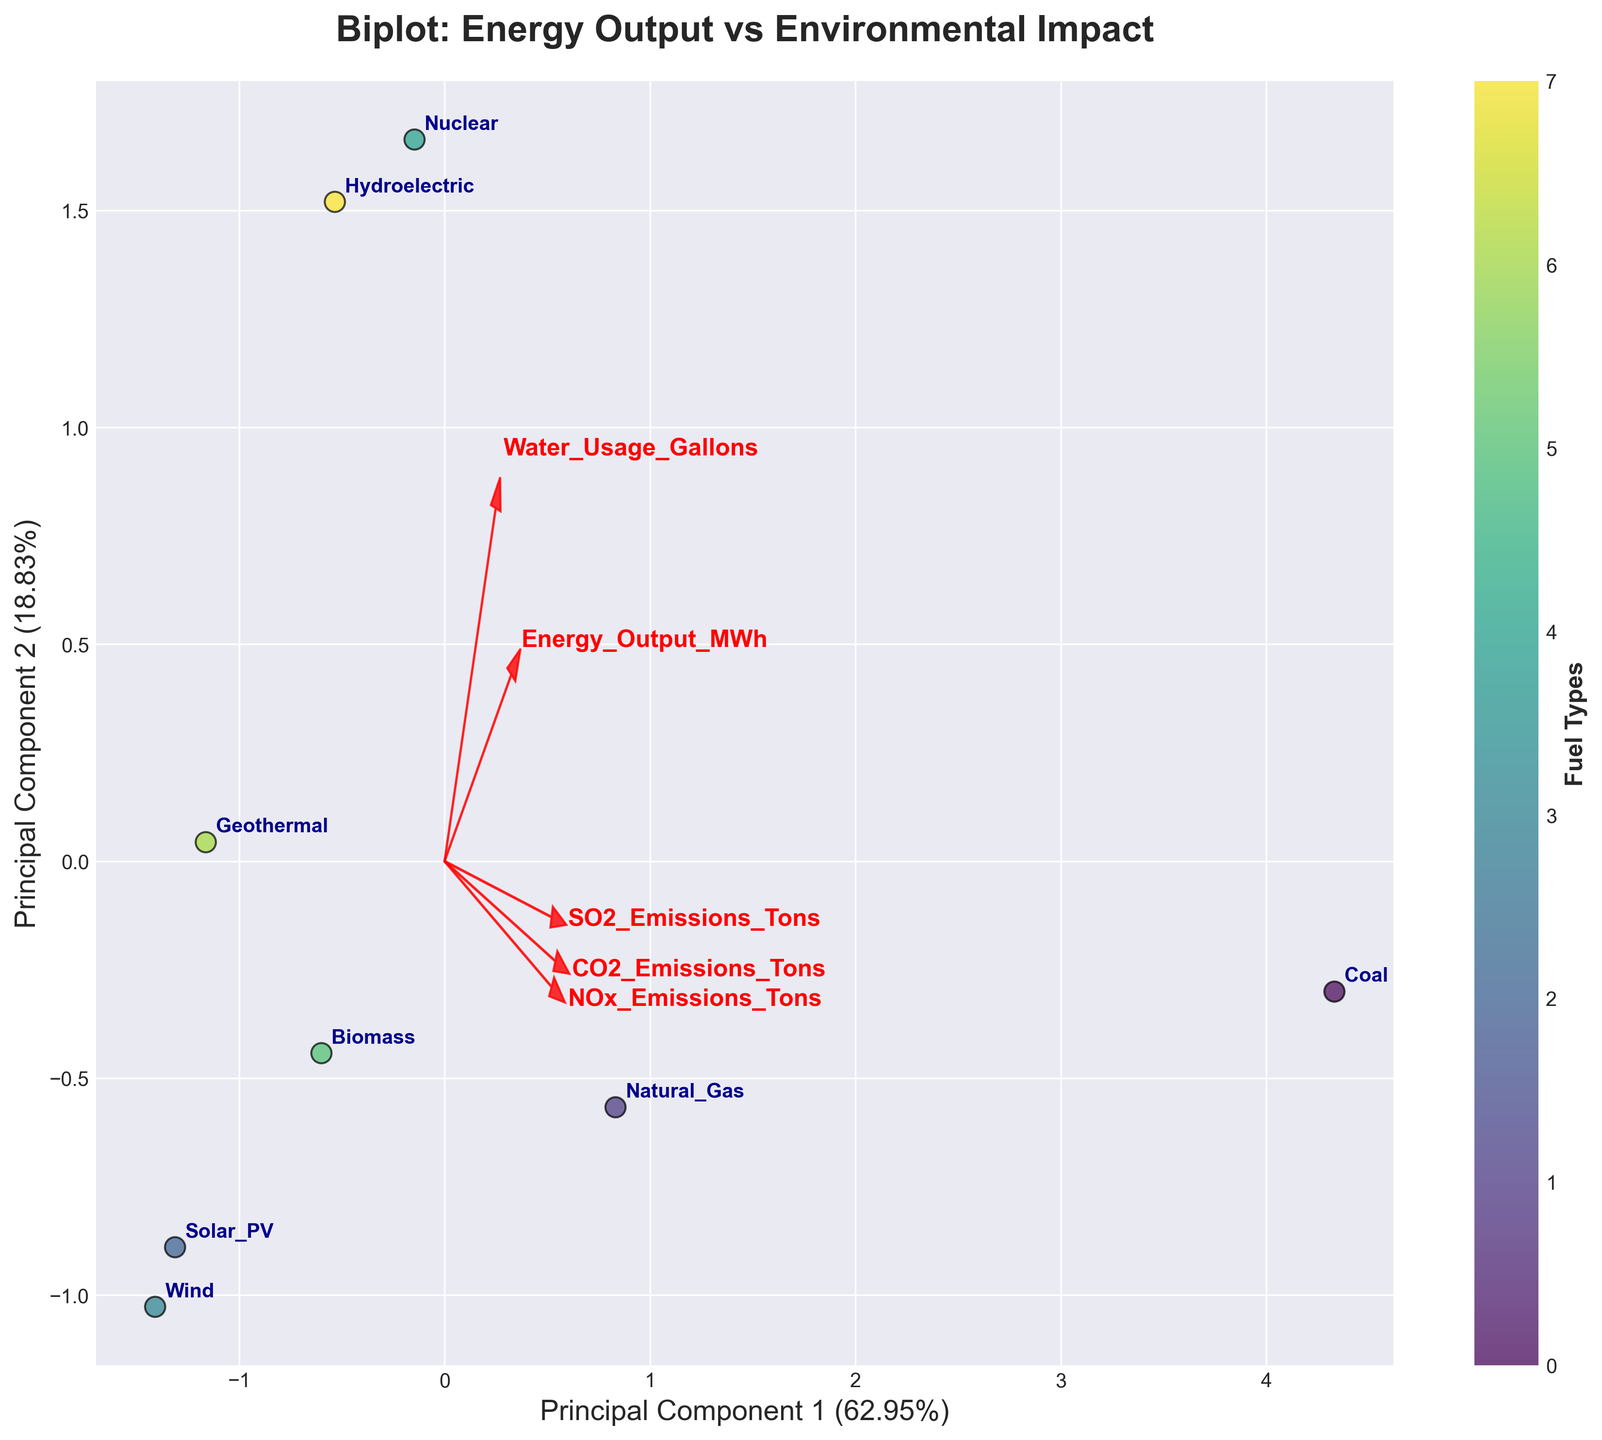What is the title of the biplot? The title is written at the top of the plot. It says 'Biplot: Energy Output vs Environmental Impact'.
Answer: Biplot: Energy Output vs Environmental Impact How many fuel types are represented in the biplot? Look at the number of data points or labels annotated on the biplot; each label represents a fuel type.
Answer: 8 Which fuel type appears to have the highest energy output based on the biplot? The position of the data points along the principal component axes may give insights into relative energy outputs. Look for the label that’s furthest in the direction corresponding to high energy output.
Answer: Nuclear Which features are most strongly associated with the first principal component? Identify the vectors (arrows) that align most closely with the first principal component (X-axis). These vectors represent the features most associated with this component.
Answer: CO2 Emissions, Energy Output, Water Usage How do coal and natural gas compare in terms of environmental impact? Locate the positions of 'Coal' and 'Natural Gas' on the plot, especially along vectors representing CO2, SO2, and NOx emissions. Coal should be closer to these vectors, indicating higher emissions.
Answer: Coal has a greater impact Which fuel type has the lowest water usage according to the biplot? Look for the label closest to the end of the vector pointing in the opposite direction of 'Water Usage Gallons'.
Answer: Wind What can you infer about solar energy's environmental impact from the biplot? Examine the position of 'Solar PV' with respect to environmental impact vectors like CO2, SO2, and NOx emissions. Solar PV should be far from these vectors, indicating low emissions.
Answer: Very low impact How do hydroelectric and nuclear compare in terms of water usage? Locate the positions of 'Hydroelectric' and 'Nuclear' in relation to the Water Usage vector. Hydroelectric should be further along the direction of the Water Usage vector.
Answer: Hydroelectric uses more water Which principal component explains more variance in the data? The labels on the axes show the percentage of variance explained by each principal component.
Answer: Principal Component 1 What is the relationship between biomass and geothermal energy regarding CO2 emissions? Compare the positions of 'Biomass' and 'Geothermal' along the CO2 emissions vector. Biomass should be closer to this vector, indicating higher CO2 emissions.
Answer: Biomass has higher CO2 emissions 